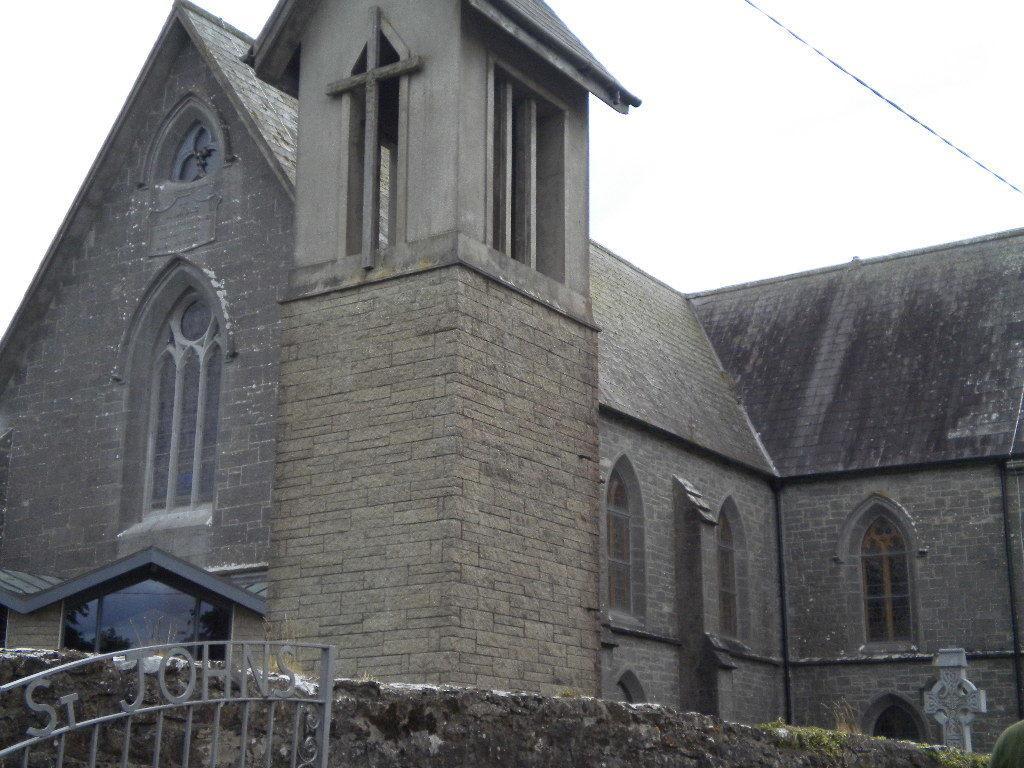Can you describe this image briefly? In the image there is a building in the back with a wall and gate in front of it and above its sky. 